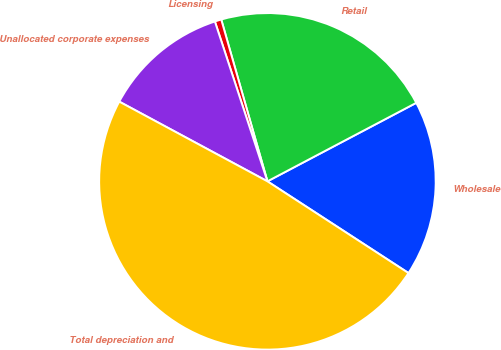Convert chart. <chart><loc_0><loc_0><loc_500><loc_500><pie_chart><fcel>Wholesale<fcel>Retail<fcel>Licensing<fcel>Unallocated corporate expenses<fcel>Total depreciation and<nl><fcel>16.9%<fcel>21.7%<fcel>0.63%<fcel>12.09%<fcel>48.68%<nl></chart> 